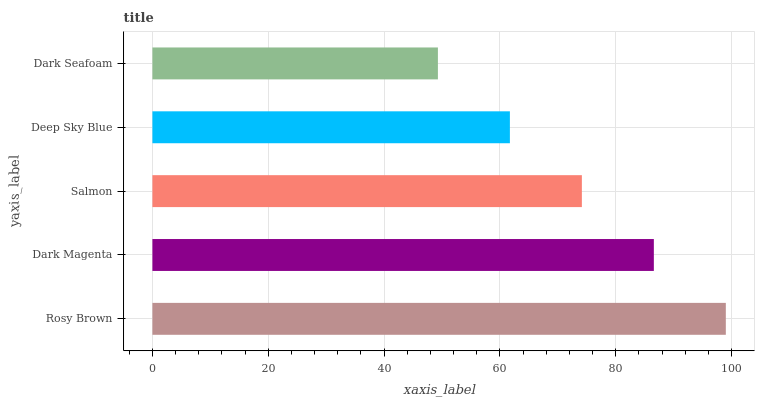Is Dark Seafoam the minimum?
Answer yes or no. Yes. Is Rosy Brown the maximum?
Answer yes or no. Yes. Is Dark Magenta the minimum?
Answer yes or no. No. Is Dark Magenta the maximum?
Answer yes or no. No. Is Rosy Brown greater than Dark Magenta?
Answer yes or no. Yes. Is Dark Magenta less than Rosy Brown?
Answer yes or no. Yes. Is Dark Magenta greater than Rosy Brown?
Answer yes or no. No. Is Rosy Brown less than Dark Magenta?
Answer yes or no. No. Is Salmon the high median?
Answer yes or no. Yes. Is Salmon the low median?
Answer yes or no. Yes. Is Rosy Brown the high median?
Answer yes or no. No. Is Dark Magenta the low median?
Answer yes or no. No. 